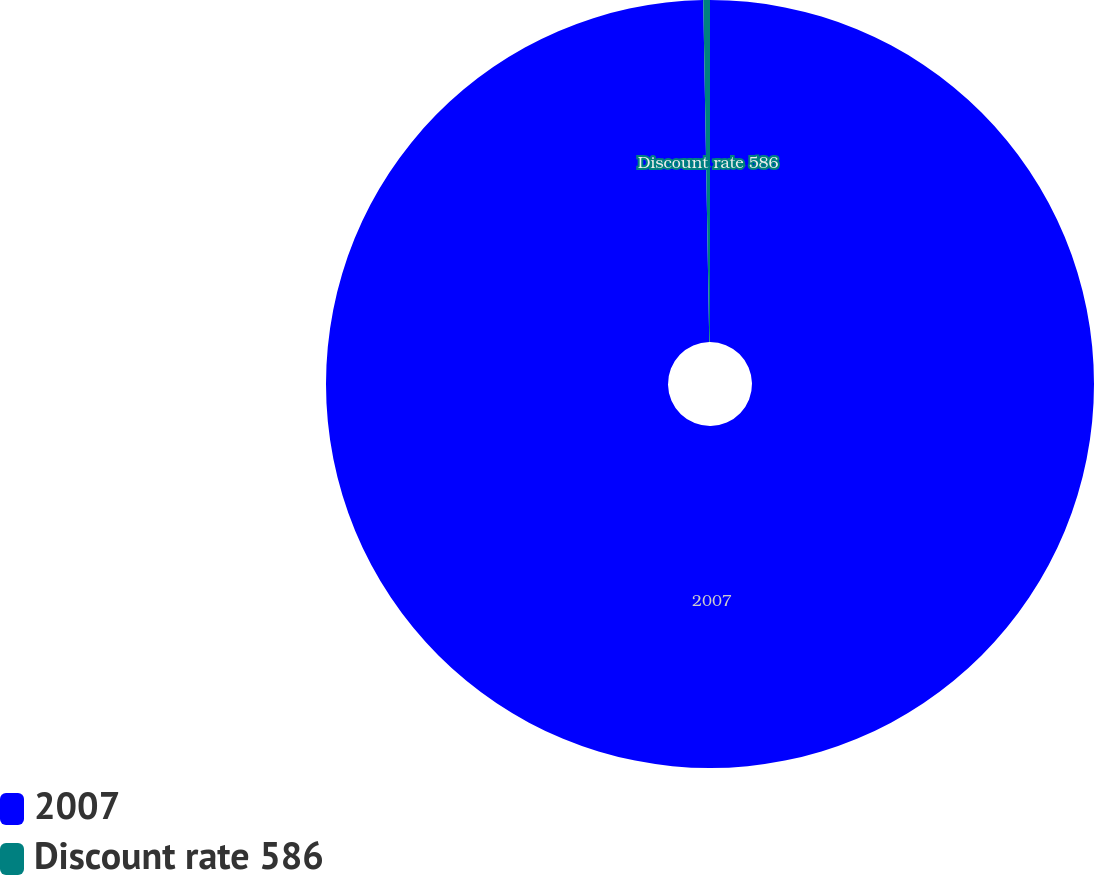Convert chart to OTSL. <chart><loc_0><loc_0><loc_500><loc_500><pie_chart><fcel>2007<fcel>Discount rate 586<nl><fcel>99.72%<fcel>0.28%<nl></chart> 